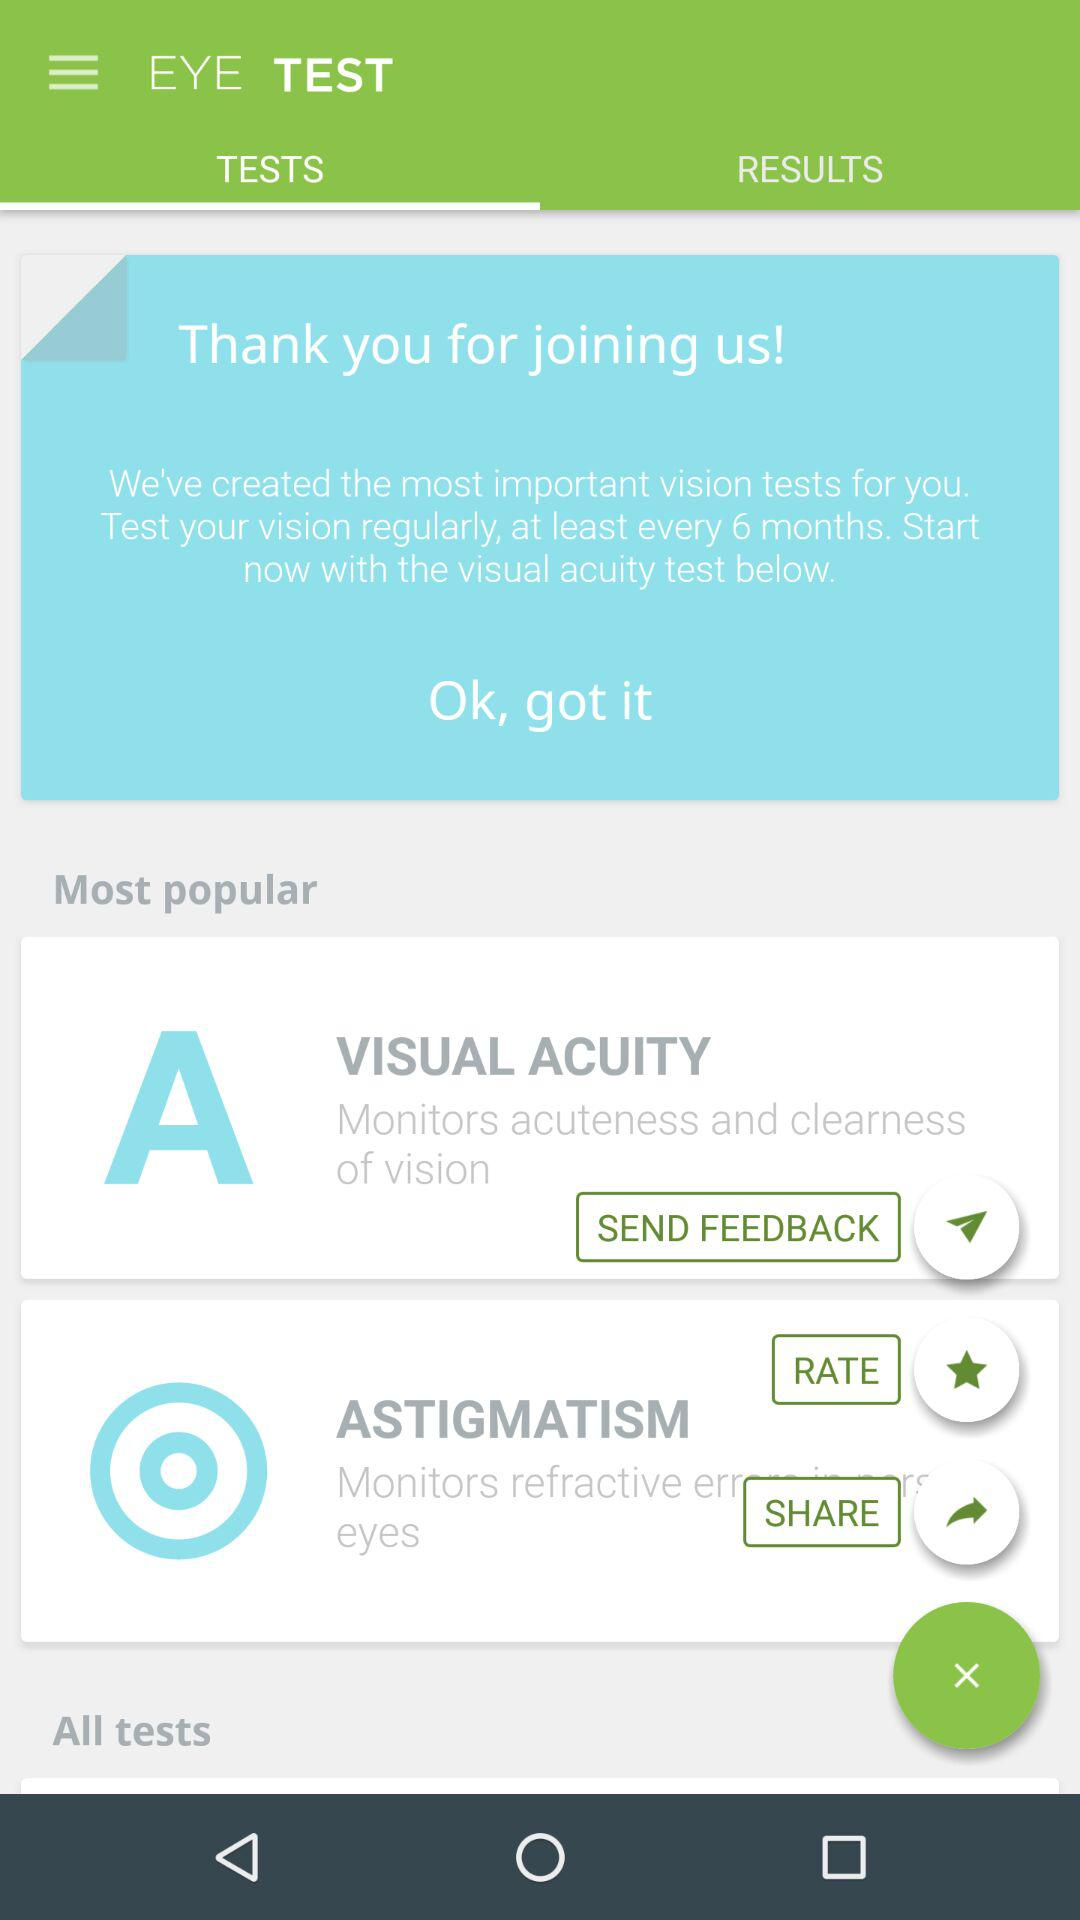How many tests are available?
Answer the question using a single word or phrase. 2 